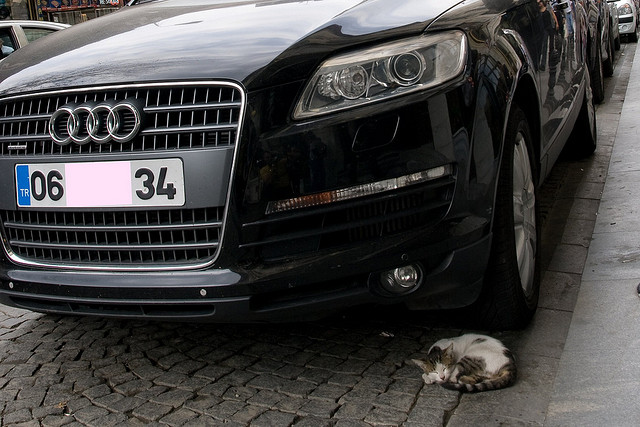<image>Why is the cat sleeping near the car's wheel? It is unknown why the cat is sleeping near the car's wheel. It could be for shade, warmth, or because it's tired. Why is the cat sleeping near the car's wheel? It is ambiguous why the cat is sleeping near the car's wheel. It can be for shade, warmth or resting. 